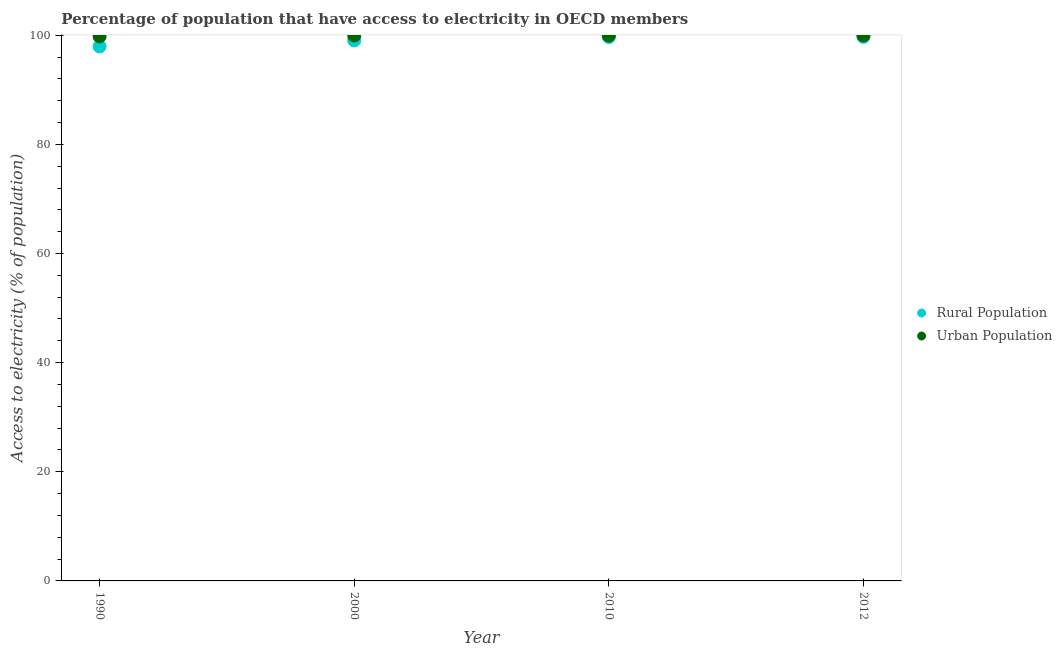What is the percentage of rural population having access to electricity in 2010?
Offer a very short reply. 99.66. Across all years, what is the maximum percentage of rural population having access to electricity?
Ensure brevity in your answer.  99.7. Across all years, what is the minimum percentage of rural population having access to electricity?
Give a very brief answer. 97.94. In which year was the percentage of rural population having access to electricity maximum?
Offer a terse response. 2012. What is the total percentage of rural population having access to electricity in the graph?
Make the answer very short. 396.34. What is the difference between the percentage of urban population having access to electricity in 1990 and that in 2012?
Make the answer very short. -0.18. What is the difference between the percentage of urban population having access to electricity in 2012 and the percentage of rural population having access to electricity in 2000?
Your response must be concise. 0.92. What is the average percentage of rural population having access to electricity per year?
Offer a very short reply. 99.09. In the year 2012, what is the difference between the percentage of rural population having access to electricity and percentage of urban population having access to electricity?
Provide a short and direct response. -0.27. In how many years, is the percentage of rural population having access to electricity greater than 84 %?
Make the answer very short. 4. What is the ratio of the percentage of urban population having access to electricity in 2010 to that in 2012?
Your response must be concise. 1. Is the difference between the percentage of urban population having access to electricity in 1990 and 2010 greater than the difference between the percentage of rural population having access to electricity in 1990 and 2010?
Make the answer very short. Yes. What is the difference between the highest and the second highest percentage of urban population having access to electricity?
Keep it short and to the point. 0.03. What is the difference between the highest and the lowest percentage of rural population having access to electricity?
Ensure brevity in your answer.  1.76. In how many years, is the percentage of rural population having access to electricity greater than the average percentage of rural population having access to electricity taken over all years?
Your response must be concise. 2. Does the percentage of rural population having access to electricity monotonically increase over the years?
Keep it short and to the point. Yes. Is the percentage of rural population having access to electricity strictly less than the percentage of urban population having access to electricity over the years?
Offer a terse response. Yes. What is the difference between two consecutive major ticks on the Y-axis?
Your response must be concise. 20. Are the values on the major ticks of Y-axis written in scientific E-notation?
Make the answer very short. No. Does the graph contain any zero values?
Give a very brief answer. No. Where does the legend appear in the graph?
Give a very brief answer. Center right. How many legend labels are there?
Provide a succinct answer. 2. What is the title of the graph?
Make the answer very short. Percentage of population that have access to electricity in OECD members. What is the label or title of the X-axis?
Keep it short and to the point. Year. What is the label or title of the Y-axis?
Provide a short and direct response. Access to electricity (% of population). What is the Access to electricity (% of population) of Rural Population in 1990?
Offer a very short reply. 97.94. What is the Access to electricity (% of population) in Urban Population in 1990?
Keep it short and to the point. 99.78. What is the Access to electricity (% of population) in Rural Population in 2000?
Make the answer very short. 99.04. What is the Access to electricity (% of population) of Urban Population in 2000?
Offer a very short reply. 99.93. What is the Access to electricity (% of population) in Rural Population in 2010?
Make the answer very short. 99.66. What is the Access to electricity (% of population) of Urban Population in 2010?
Your answer should be very brief. 99.93. What is the Access to electricity (% of population) of Rural Population in 2012?
Provide a succinct answer. 99.7. What is the Access to electricity (% of population) of Urban Population in 2012?
Make the answer very short. 99.96. Across all years, what is the maximum Access to electricity (% of population) in Rural Population?
Offer a terse response. 99.7. Across all years, what is the maximum Access to electricity (% of population) of Urban Population?
Make the answer very short. 99.96. Across all years, what is the minimum Access to electricity (% of population) of Rural Population?
Your answer should be compact. 97.94. Across all years, what is the minimum Access to electricity (% of population) in Urban Population?
Provide a short and direct response. 99.78. What is the total Access to electricity (% of population) in Rural Population in the graph?
Provide a succinct answer. 396.34. What is the total Access to electricity (% of population) in Urban Population in the graph?
Provide a short and direct response. 399.6. What is the difference between the Access to electricity (% of population) in Rural Population in 1990 and that in 2000?
Your answer should be compact. -1.1. What is the difference between the Access to electricity (% of population) of Urban Population in 1990 and that in 2000?
Keep it short and to the point. -0.15. What is the difference between the Access to electricity (% of population) of Rural Population in 1990 and that in 2010?
Give a very brief answer. -1.72. What is the difference between the Access to electricity (% of population) in Urban Population in 1990 and that in 2010?
Give a very brief answer. -0.15. What is the difference between the Access to electricity (% of population) of Rural Population in 1990 and that in 2012?
Make the answer very short. -1.76. What is the difference between the Access to electricity (% of population) in Urban Population in 1990 and that in 2012?
Provide a short and direct response. -0.18. What is the difference between the Access to electricity (% of population) in Rural Population in 2000 and that in 2010?
Your answer should be very brief. -0.62. What is the difference between the Access to electricity (% of population) of Urban Population in 2000 and that in 2010?
Keep it short and to the point. -0. What is the difference between the Access to electricity (% of population) in Rural Population in 2000 and that in 2012?
Your response must be concise. -0.65. What is the difference between the Access to electricity (% of population) in Urban Population in 2000 and that in 2012?
Give a very brief answer. -0.03. What is the difference between the Access to electricity (% of population) of Rural Population in 2010 and that in 2012?
Your answer should be very brief. -0.03. What is the difference between the Access to electricity (% of population) in Urban Population in 2010 and that in 2012?
Keep it short and to the point. -0.03. What is the difference between the Access to electricity (% of population) of Rural Population in 1990 and the Access to electricity (% of population) of Urban Population in 2000?
Offer a very short reply. -1.99. What is the difference between the Access to electricity (% of population) of Rural Population in 1990 and the Access to electricity (% of population) of Urban Population in 2010?
Make the answer very short. -1.99. What is the difference between the Access to electricity (% of population) of Rural Population in 1990 and the Access to electricity (% of population) of Urban Population in 2012?
Make the answer very short. -2.02. What is the difference between the Access to electricity (% of population) of Rural Population in 2000 and the Access to electricity (% of population) of Urban Population in 2010?
Your answer should be compact. -0.89. What is the difference between the Access to electricity (% of population) in Rural Population in 2000 and the Access to electricity (% of population) in Urban Population in 2012?
Provide a succinct answer. -0.92. What is the difference between the Access to electricity (% of population) of Rural Population in 2010 and the Access to electricity (% of population) of Urban Population in 2012?
Offer a terse response. -0.3. What is the average Access to electricity (% of population) of Rural Population per year?
Your answer should be very brief. 99.09. What is the average Access to electricity (% of population) of Urban Population per year?
Offer a very short reply. 99.9. In the year 1990, what is the difference between the Access to electricity (% of population) of Rural Population and Access to electricity (% of population) of Urban Population?
Your answer should be very brief. -1.84. In the year 2000, what is the difference between the Access to electricity (% of population) in Rural Population and Access to electricity (% of population) in Urban Population?
Provide a succinct answer. -0.89. In the year 2010, what is the difference between the Access to electricity (% of population) of Rural Population and Access to electricity (% of population) of Urban Population?
Offer a very short reply. -0.27. In the year 2012, what is the difference between the Access to electricity (% of population) of Rural Population and Access to electricity (% of population) of Urban Population?
Provide a succinct answer. -0.27. What is the ratio of the Access to electricity (% of population) of Rural Population in 1990 to that in 2000?
Give a very brief answer. 0.99. What is the ratio of the Access to electricity (% of population) of Rural Population in 1990 to that in 2010?
Offer a very short reply. 0.98. What is the ratio of the Access to electricity (% of population) in Rural Population in 1990 to that in 2012?
Give a very brief answer. 0.98. What is the ratio of the Access to electricity (% of population) of Urban Population in 2000 to that in 2010?
Keep it short and to the point. 1. What is the ratio of the Access to electricity (% of population) in Rural Population in 2000 to that in 2012?
Offer a terse response. 0.99. What is the ratio of the Access to electricity (% of population) in Urban Population in 2000 to that in 2012?
Your answer should be compact. 1. What is the ratio of the Access to electricity (% of population) in Rural Population in 2010 to that in 2012?
Make the answer very short. 1. What is the difference between the highest and the second highest Access to electricity (% of population) in Rural Population?
Provide a succinct answer. 0.03. What is the difference between the highest and the second highest Access to electricity (% of population) in Urban Population?
Your answer should be very brief. 0.03. What is the difference between the highest and the lowest Access to electricity (% of population) of Rural Population?
Your answer should be compact. 1.76. What is the difference between the highest and the lowest Access to electricity (% of population) in Urban Population?
Give a very brief answer. 0.18. 